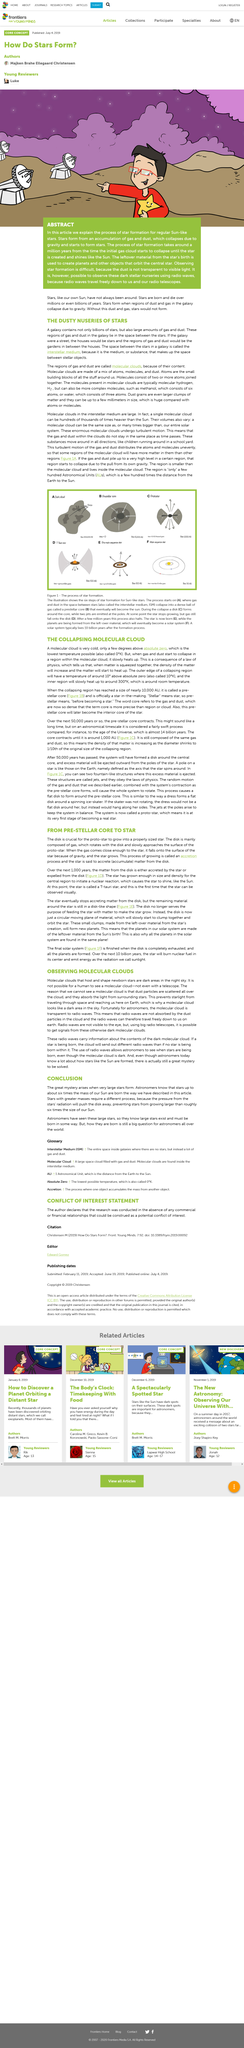Point out several critical features in this image. The great mystery arises when very large stars form. Galaxies are comprised of stars, gas, and dust, which collectively form the building blocks of our universe. The disk is mainly composed of gas. Molecular clouds, which are dense regions of gas and dust in space, are transparent to radio waves. This means that radio waves can pass through these clouds without being absorbed or scattered. These clouds are so dense that they block visible light, but they allow radio waves to pass through, making them visible to radio telescopes. It is not possible for a human to see a molecular cloud, not even with a telescope, as observing molecular clouds requires specialized equipment and techniques that are beyond the capabilities of human observation. 